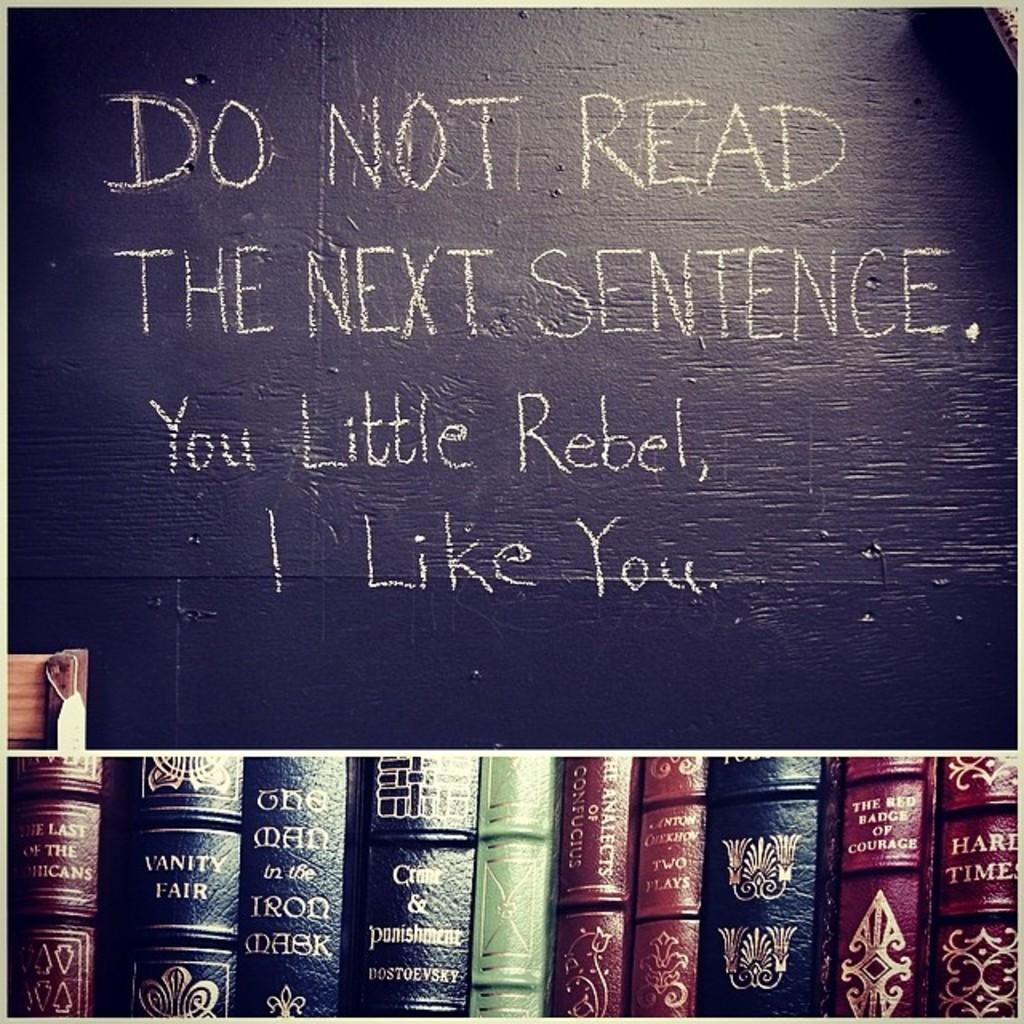<image>
Relay a brief, clear account of the picture shown. A sign displayed above books stays Do Not Read The Next Sentence 